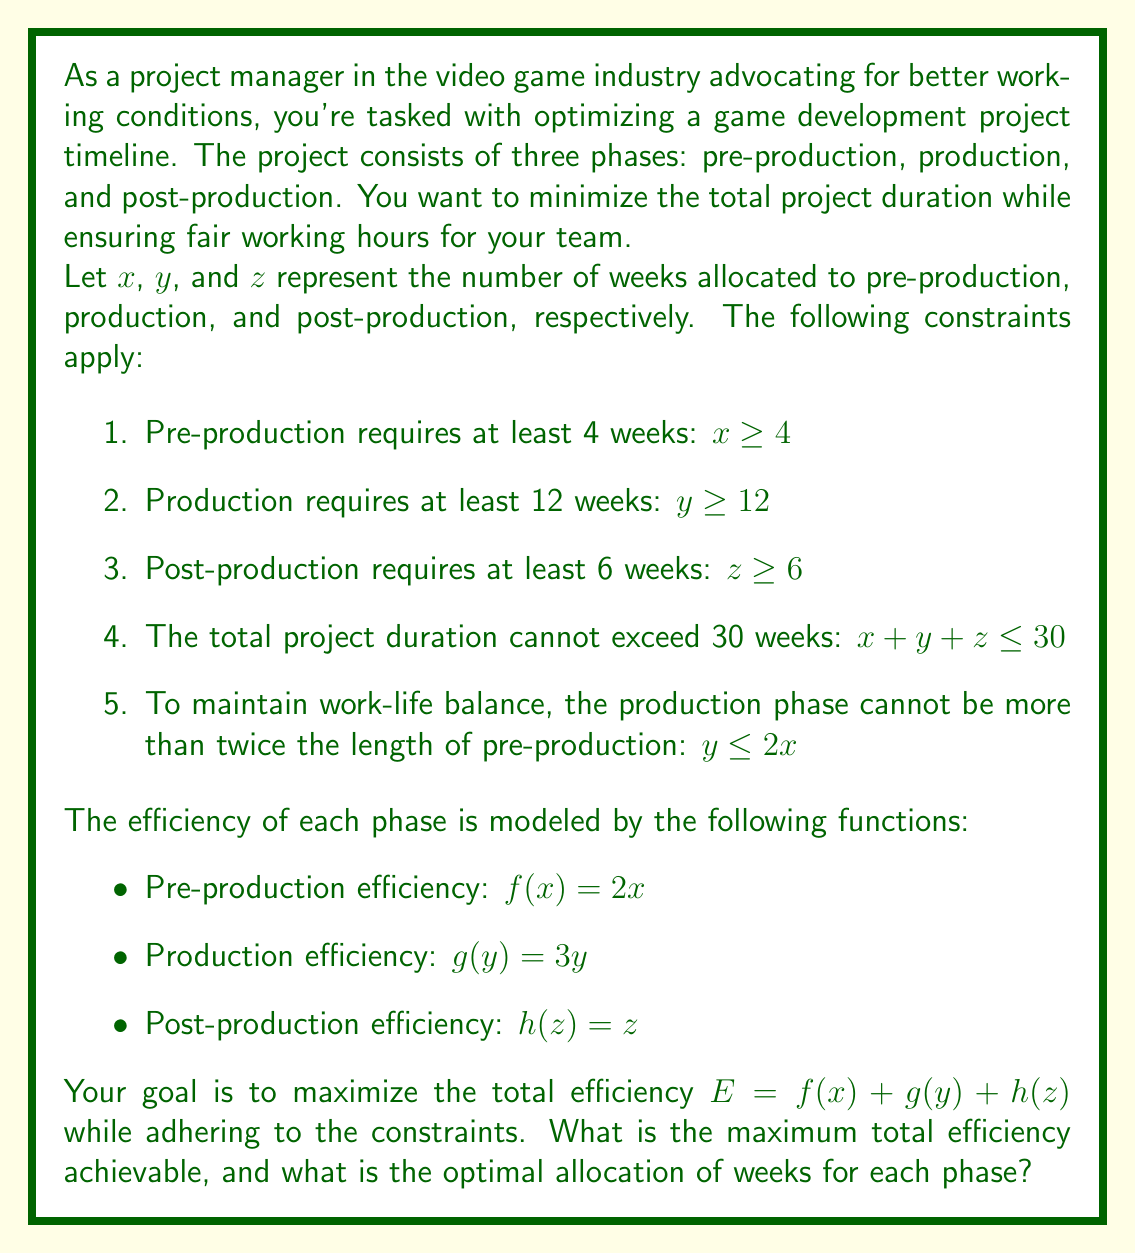Solve this math problem. To solve this linear programming problem, we'll use the simplex method. First, let's set up our objective function and constraints:

Maximize: $E = 2x + 3y + z$

Subject to:
1. $x \geq 4$
2. $y \geq 12$
3. $z \geq 6$
4. $x + y + z \leq 30$
5. $y \leq 2x$

We'll convert inequality constraints to equality constraints by introducing slack variables:

1. $x - s_1 = 4$
2. $y - s_2 = 12$
3. $z - s_3 = 6$
4. $x + y + z + s_4 = 30$
5. $-2x + y + s_5 = 0$

Now, we'll set up the initial simplex tableau:

$$
\begin{array}{c|ccccccccc|c}
 & x & y & z & s_1 & s_2 & s_3 & s_4 & s_5 & RHS \\
\hline
E & -2 & -3 & -1 & 0 & 0 & 0 & 0 & 0 & 0 \\
s_1 & 1 & 0 & 0 & 1 & 0 & 0 & 0 & 0 & 4 \\
s_2 & 0 & 1 & 0 & 0 & 1 & 0 & 0 & 0 & 12 \\
s_3 & 0 & 0 & 1 & 0 & 0 & 1 & 0 & 0 & 6 \\
s_4 & 1 & 1 & 1 & 0 & 0 & 0 & 1 & 0 & 30 \\
s_5 & -2 & 1 & 0 & 0 & 0 & 0 & 0 & 1 & 0 \\
\end{array}
$$

After performing pivot operations to optimize the solution, we arrive at the final tableau:

$$
\begin{array}{c|ccccccccc|c}
 & x & y & z & s_1 & s_2 & s_3 & s_4 & s_5 & RHS \\
\hline
E & 0 & 0 & 0 & 0 & 1 & 1 & 2 & 0 & 78 \\
x & 1 & 0 & 0 & 0 & 0 & 0 & 0 & 1/2 & 8 \\
y & 0 & 1 & 0 & 0 & 1 & 0 & 0 & 0 & 16 \\
z & 0 & 0 & 1 & 0 & 0 & 1 & 0 & 0 & 6 \\
s_4 & 0 & 0 & 0 & 0 & -1 & -1 & 1 & -1/2 & 0 \\
s_1 & 0 & 0 & 0 & 1 & 0 & 0 & 0 & -1/2 & 4 \\
\end{array}
$$

From this final tableau, we can read the optimal solution:
- $x = 8$ weeks for pre-production
- $y = 16$ weeks for production
- $z = 6$ weeks for post-production
- Maximum total efficiency $E = 78$
Answer: The maximum total efficiency achievable is 78, with the optimal allocation of weeks being 8 weeks for pre-production, 16 weeks for production, and 6 weeks for post-production. 